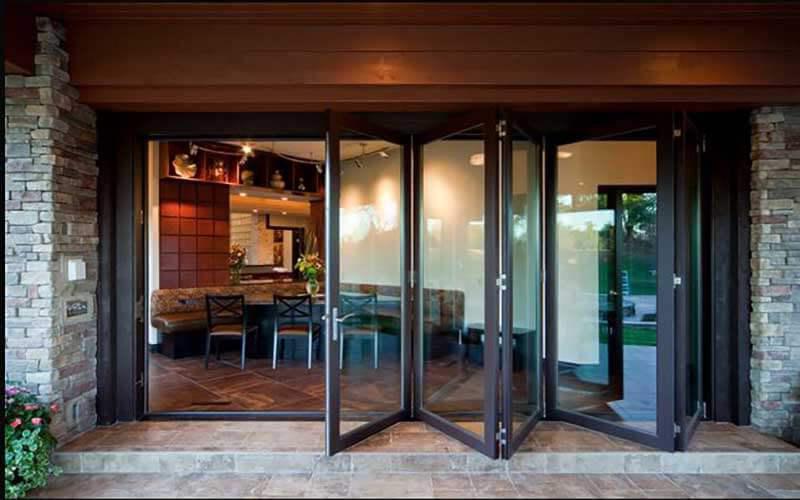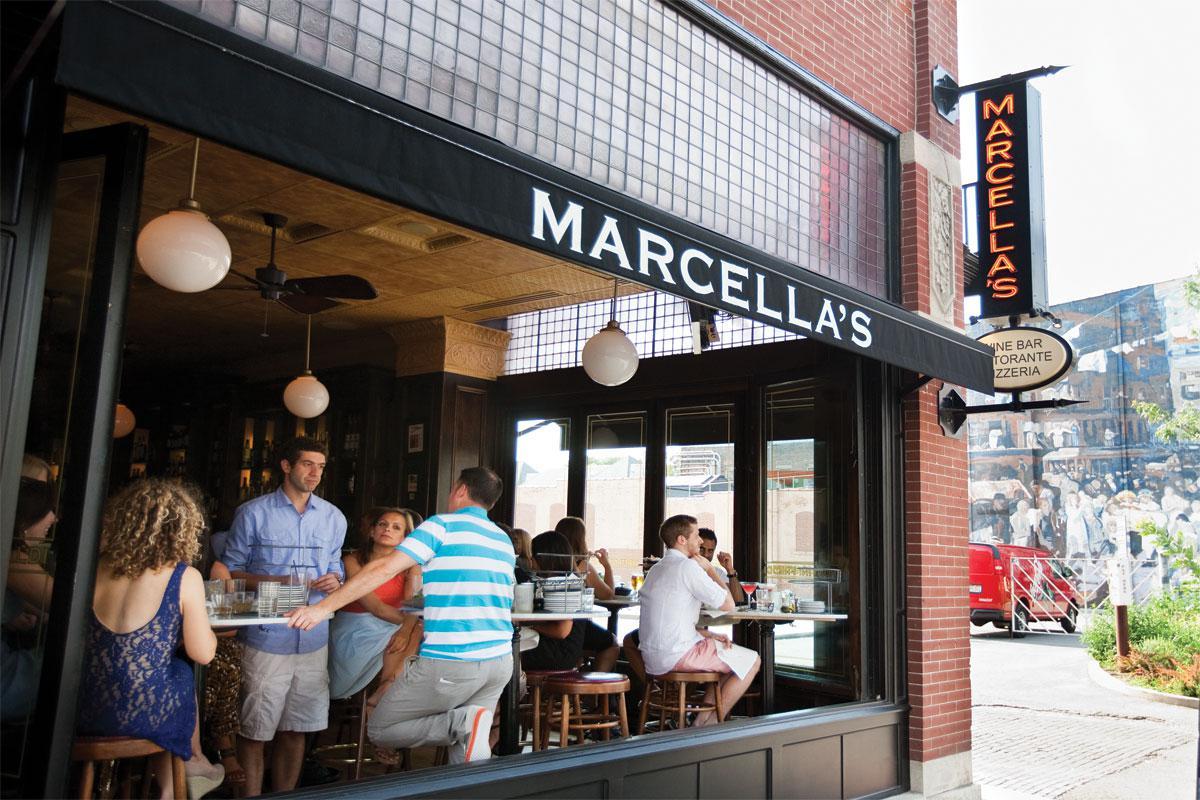The first image is the image on the left, the second image is the image on the right. For the images shown, is this caption "One image is inside and one is outside." true? Answer yes or no. No. The first image is the image on the left, the second image is the image on the right. Evaluate the accuracy of this statement regarding the images: "There is a five glass panel and black trim set of doors acorning.". Is it true? Answer yes or no. Yes. 